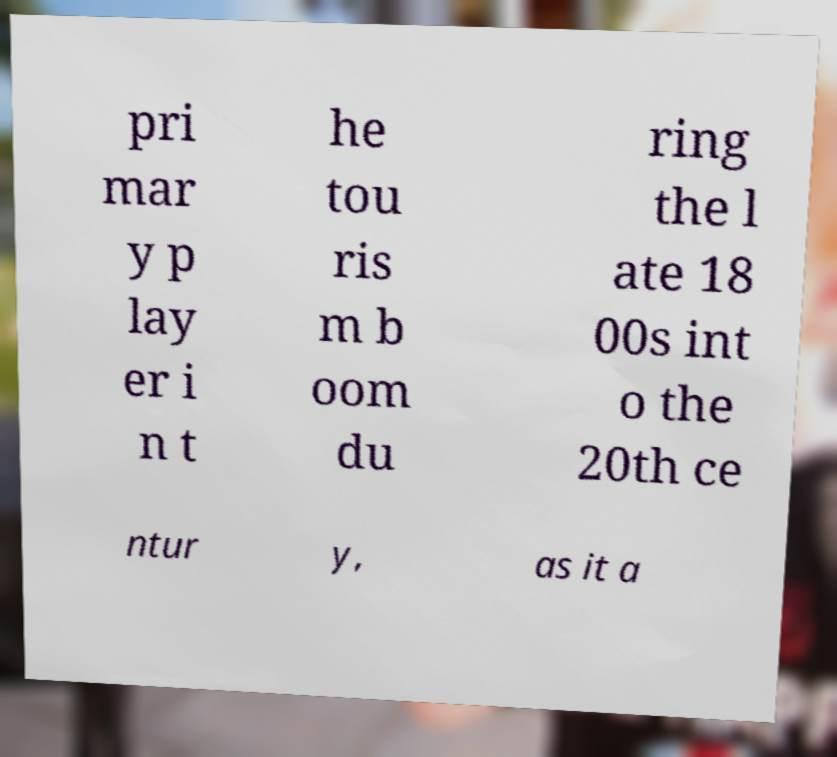Can you accurately transcribe the text from the provided image for me? pri mar y p lay er i n t he tou ris m b oom du ring the l ate 18 00s int o the 20th ce ntur y, as it a 